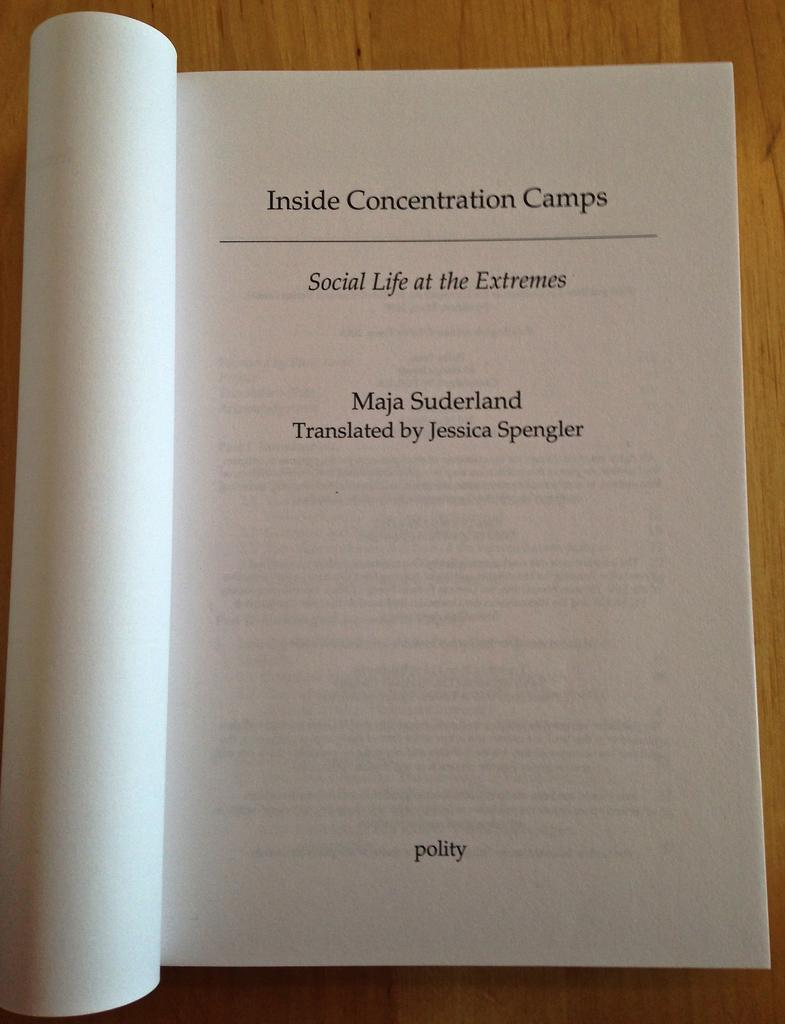<image>
Offer a succinct explanation of the picture presented. A book opened to a page with Inside Concentration Camps at the top of the page. 